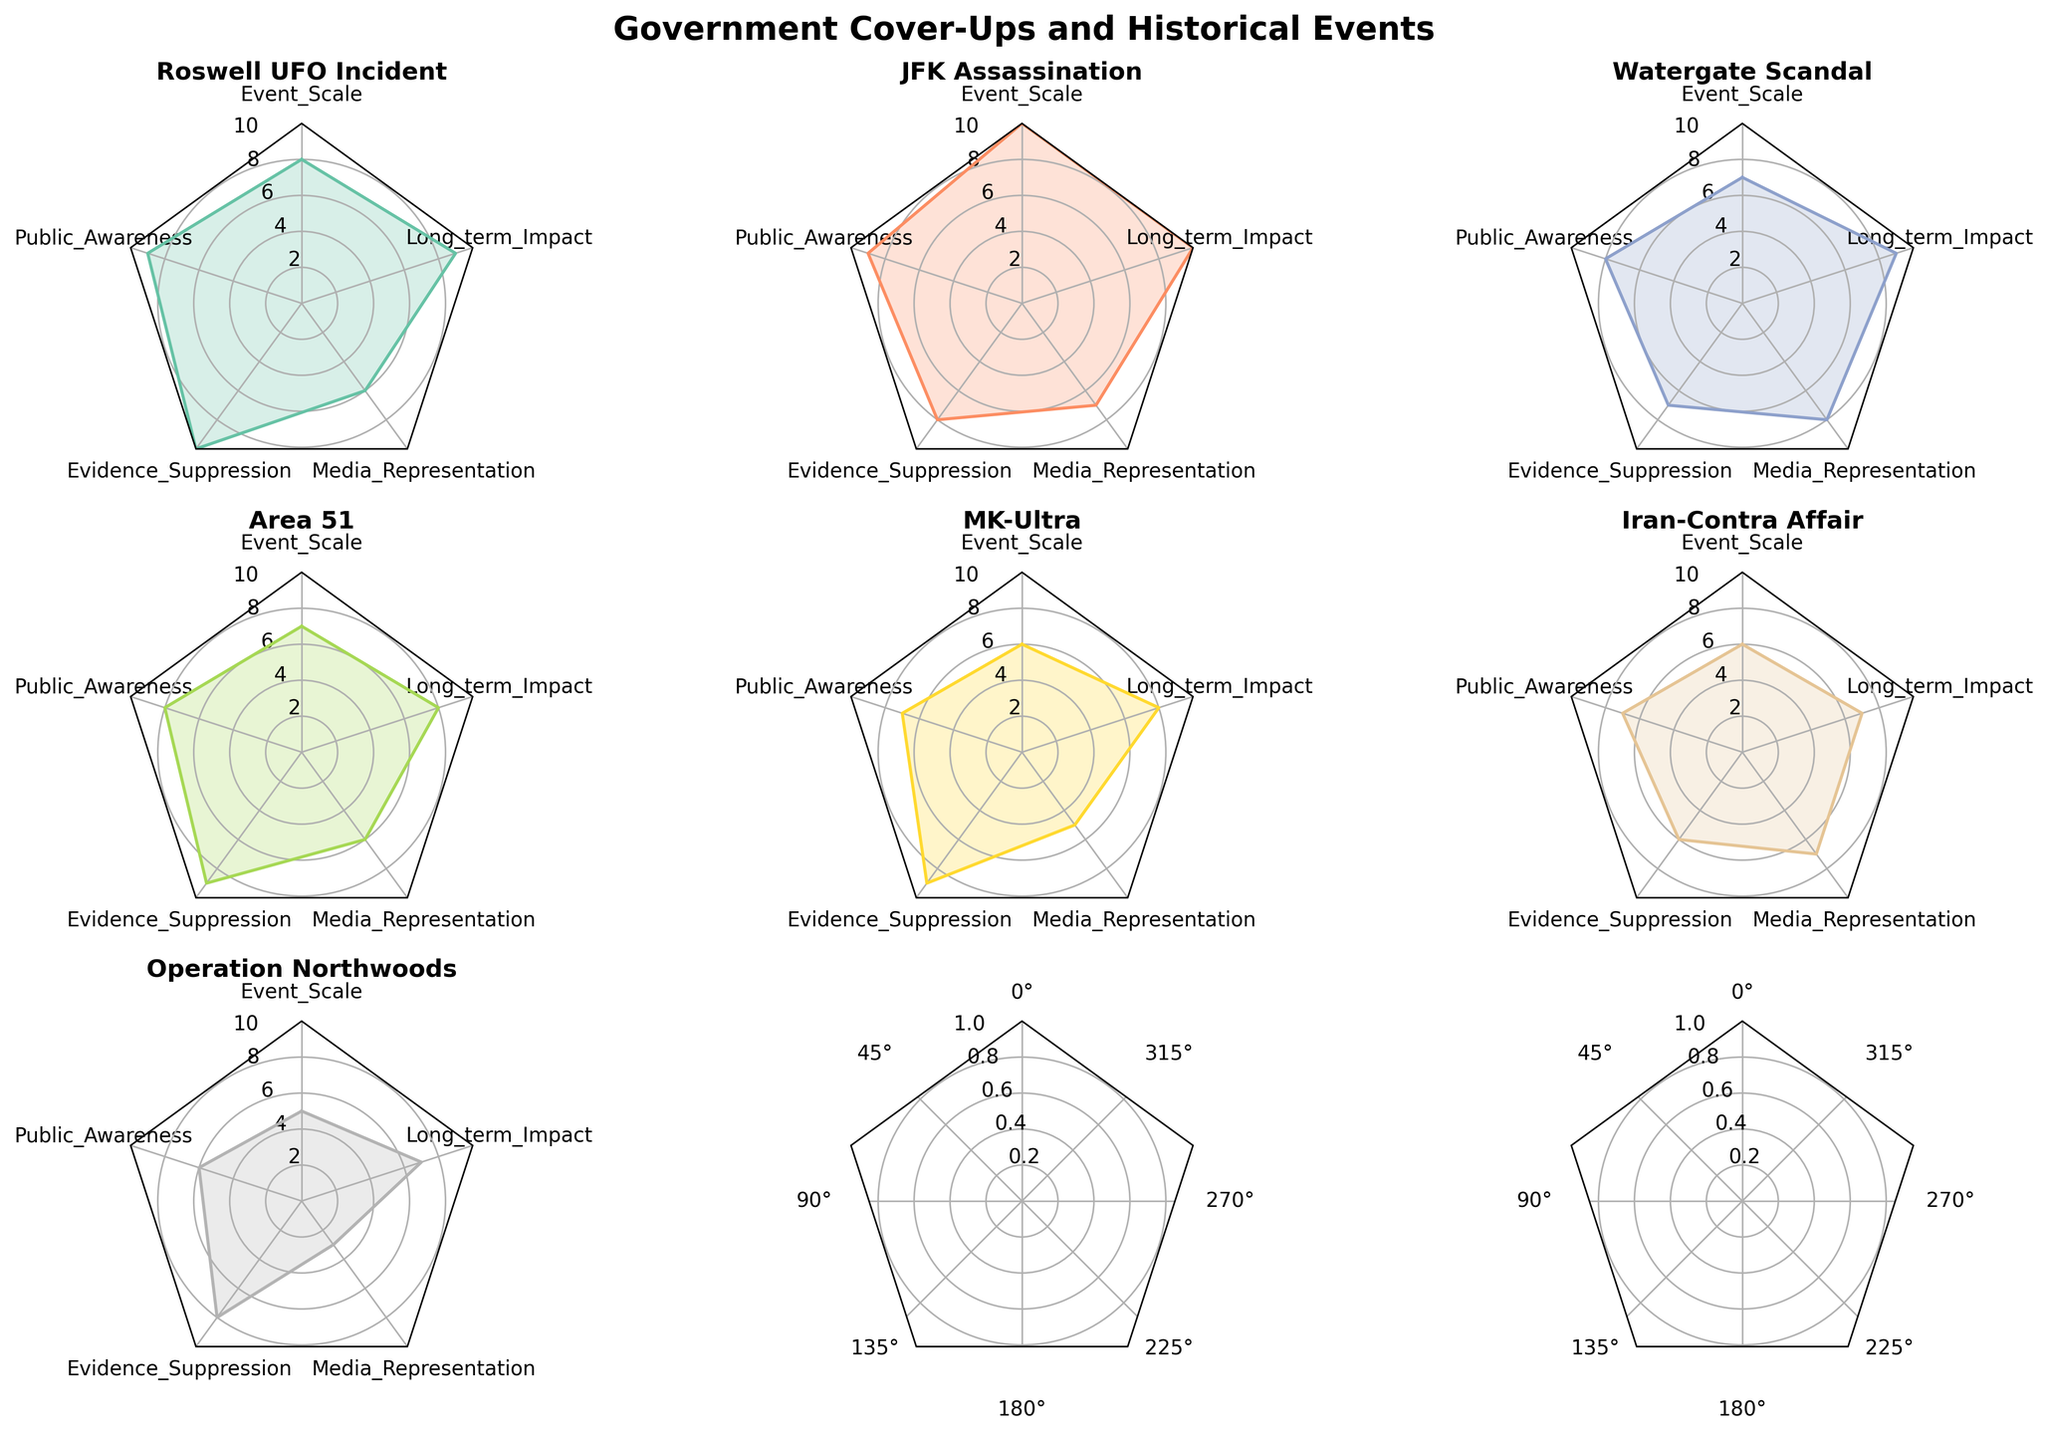What's the title of the figure? The title is usually displayed prominently at the top of the figure. According to the given code, it is set as "Government Cover-Ups and Historical Events".
Answer: Government Cover-Ups and Historical Events Which historical event has the highest Evidence Suppression value? By examining the values for Evidence Suppression across different events, "Roswell UFO Incident" stands out with the highest value of 10.
Answer: Roswell UFO Incident What's the median value of Long-term Impact across all events? To find the median, first arrange Long-term Impact values in ascending order: 7, 7, 7, 8, 8, 9, 10. The median, or middle number, in this sequence is the fourth value.
Answer: 8 Which event has the smallest Public Awareness value? Comparing the Public Awareness values, "Operation Northwoods" has the lowest value of 6.
Answer: Operation Northwoods How does the Media Representation of the "MK-Ultra" compare to the "Watergate Scandal"? "MK-Ultra" has a Media Representation value of 5, while "Watergate Scandal" has a value of 8. Watergate Scandal is represented more in the media.
Answer: Watergate Scandal has a higher value Which event has more long-term impact, "Iran-Contra Affair" or "Area 51"? Comparing Long-term Impact values, "Area 51" has a value of 8, and "Iran-Contra Affair" has a value of 7. Thus, "Area 51" has a higher long-term impact.
Answer: Area 51 Which event has greater Evidence Suppression than Public Awareness? By comparing values for each event: 
- Roswell (10 vs. 9), 
- JFK (8 vs. 9), 
- Watergate (7 vs. 8), 
- Area 51 (9 vs. 8), 
- MK-Ultra (9 vs. 7), 
- Iran-Contra (6 vs. 7), 
- Operation Northwoods (8 vs. 6). 
Only Roswell, Area 51, MK-Ultra, and Operation Northwoods meet this criterion.
Answer: Roswell, Area 51, MK-Ultra, Operation Northwoods Which event has the highest combination of Event Scale and Long-term Impact? By summing Event Scale and Long-term Impact for each event:
- Roswell (8 + 9 = 17)
- JFK (10 + 10 = 20)
- Watergate (7 + 9 = 16)
- Area 51 (7 + 8 = 15)
- MK-Ultra (6 + 8 = 14)
- Iran-Contra (6 + 7 = 13)
- Operation Northwoods (5 + 7 = 12). 
JFK has the highest combined value of 20.
Answer: JFK Assassination What's the average Public Awareness value for all events? Summing the Public Awareness values (9 + 9 + 8 + 8 + 7 + 7 + 6 = 54) and dividing by the number of events (7) gives the average: 54 / 7 = 7.71.
Answer: 7.71 